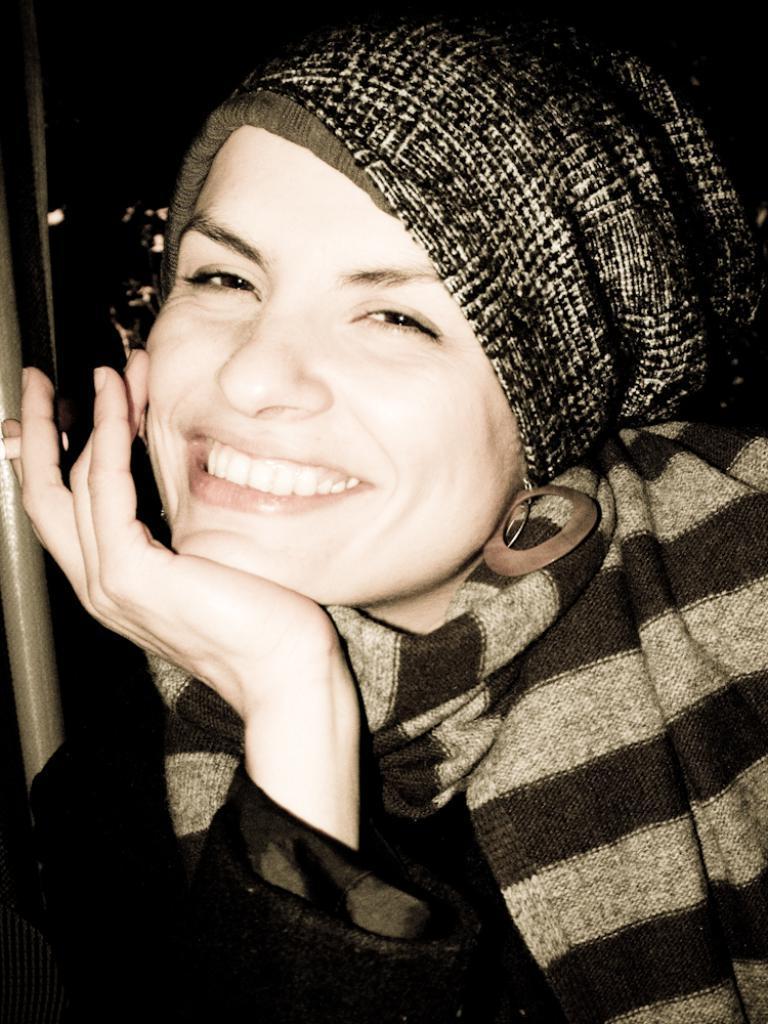How would you summarize this image in a sentence or two? In the picture we can see a woman keeping her hand to the chin and smiling and on her head we can see a cloth. 